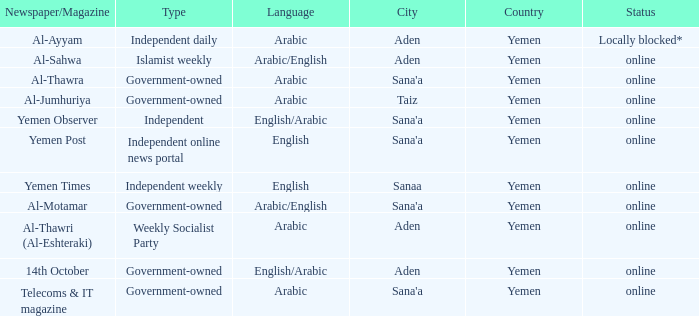What is Headquarter, when Type is Independent Online News Portal? Sana'a. Help me parse the entirety of this table. {'header': ['Newspaper/Magazine', 'Type', 'Language', 'City', 'Country', 'Status'], 'rows': [['Al-Ayyam', 'Independent daily', 'Arabic', 'Aden', 'Yemen', 'Locally blocked*'], ['Al-Sahwa', 'Islamist weekly', 'Arabic/English', 'Aden', 'Yemen', 'online'], ['Al-Thawra', 'Government-owned', 'Arabic', "Sana'a", 'Yemen', 'online'], ['Al-Jumhuriya', 'Government-owned', 'Arabic', 'Taiz', 'Yemen', 'online'], ['Yemen Observer', 'Independent', 'English/Arabic', "Sana'a", 'Yemen', 'online'], ['Yemen Post', 'Independent online news portal', 'English', "Sana'a", 'Yemen', 'online'], ['Yemen Times', 'Independent weekly', 'English', 'Sanaa', 'Yemen', 'online'], ['Al-Motamar', 'Government-owned', 'Arabic/English', "Sana'a", 'Yemen', 'online'], ['Al-Thawri (Al-Eshteraki)', 'Weekly Socialist Party', 'Arabic', 'Aden', 'Yemen', 'online'], ['14th October', 'Government-owned', 'English/Arabic', 'Aden', 'Yemen', 'online'], ['Telecoms & IT magazine', 'Government-owned', 'Arabic', "Sana'a", 'Yemen', 'online']]} 